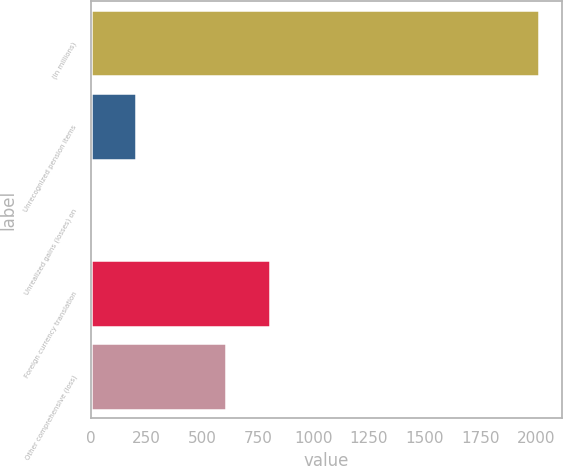Convert chart. <chart><loc_0><loc_0><loc_500><loc_500><bar_chart><fcel>(In millions)<fcel>Unrecognized pension items<fcel>Unrealized gains (losses) on<fcel>Foreign currency translation<fcel>Other comprehensive (loss)<nl><fcel>2016<fcel>201.87<fcel>0.3<fcel>806.58<fcel>605.01<nl></chart> 